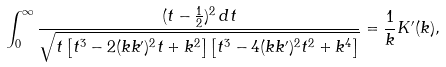Convert formula to latex. <formula><loc_0><loc_0><loc_500><loc_500>\int _ { 0 } ^ { \infty } \frac { ( t - \frac { 1 } { 2 } ) ^ { 2 } \, d t } { \sqrt { t \left [ t ^ { 3 } - 2 ( k k ^ { \prime } ) ^ { 2 } t + k ^ { 2 } \right ] \left [ t ^ { 3 } - 4 ( k k ^ { \prime } ) ^ { 2 } t ^ { 2 } + k ^ { 4 } \right ] } } = \frac { 1 } { k } K ^ { \prime } ( k ) ,</formula> 